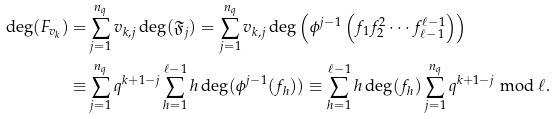Convert formula to latex. <formula><loc_0><loc_0><loc_500><loc_500>\deg ( F _ { { v } _ { k } } ) = & \sum _ { j = 1 } ^ { n _ { q } } { v } _ { k , j } \deg ( \mathfrak { F } _ { j } ) = \sum _ { j = 1 } ^ { n _ { q } } { v } _ { k , j } \deg \left ( \phi ^ { j - 1 } \left ( f _ { 1 } f _ { 2 } ^ { 2 } \cdots f _ { \ell - 1 } ^ { \ell - 1 } \right ) \right ) \\ \equiv & \sum _ { j = 1 } ^ { n _ { q } } q ^ { k + 1 - j } \sum _ { h = 1 } ^ { \ell - 1 } h \deg ( \phi ^ { j - 1 } ( f _ { h } ) ) \equiv \sum _ { h = 1 } ^ { \ell - 1 } h \deg ( f _ { h } ) \sum _ { j = 1 } ^ { n _ { q } } q ^ { k + 1 - j } \bmod { \ell } .</formula> 